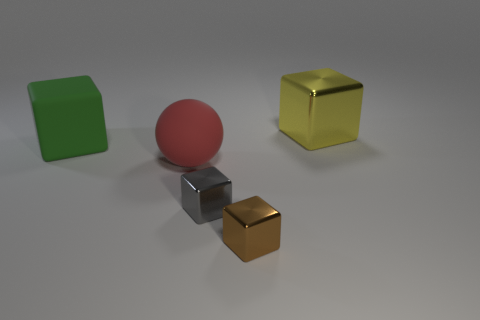How many large things have the same color as the sphere?
Keep it short and to the point. 0. Is the shape of the green object the same as the gray thing?
Offer a very short reply. Yes. Are there any other things that are the same size as the brown block?
Your answer should be very brief. Yes. There is a brown object that is the same shape as the gray thing; what is its size?
Keep it short and to the point. Small. Is the number of red balls that are behind the tiny gray metal thing greater than the number of balls that are in front of the red rubber ball?
Your answer should be very brief. Yes. Do the big green block and the big block behind the big green thing have the same material?
Offer a very short reply. No. Is there any other thing that has the same shape as the brown shiny object?
Make the answer very short. Yes. What is the color of the metal object that is in front of the large sphere and on the right side of the small gray metal block?
Your response must be concise. Brown. The big rubber thing that is in front of the large green matte object has what shape?
Offer a terse response. Sphere. There is a block that is on the left side of the big matte thing in front of the matte object to the left of the big red thing; how big is it?
Your answer should be compact. Large. 